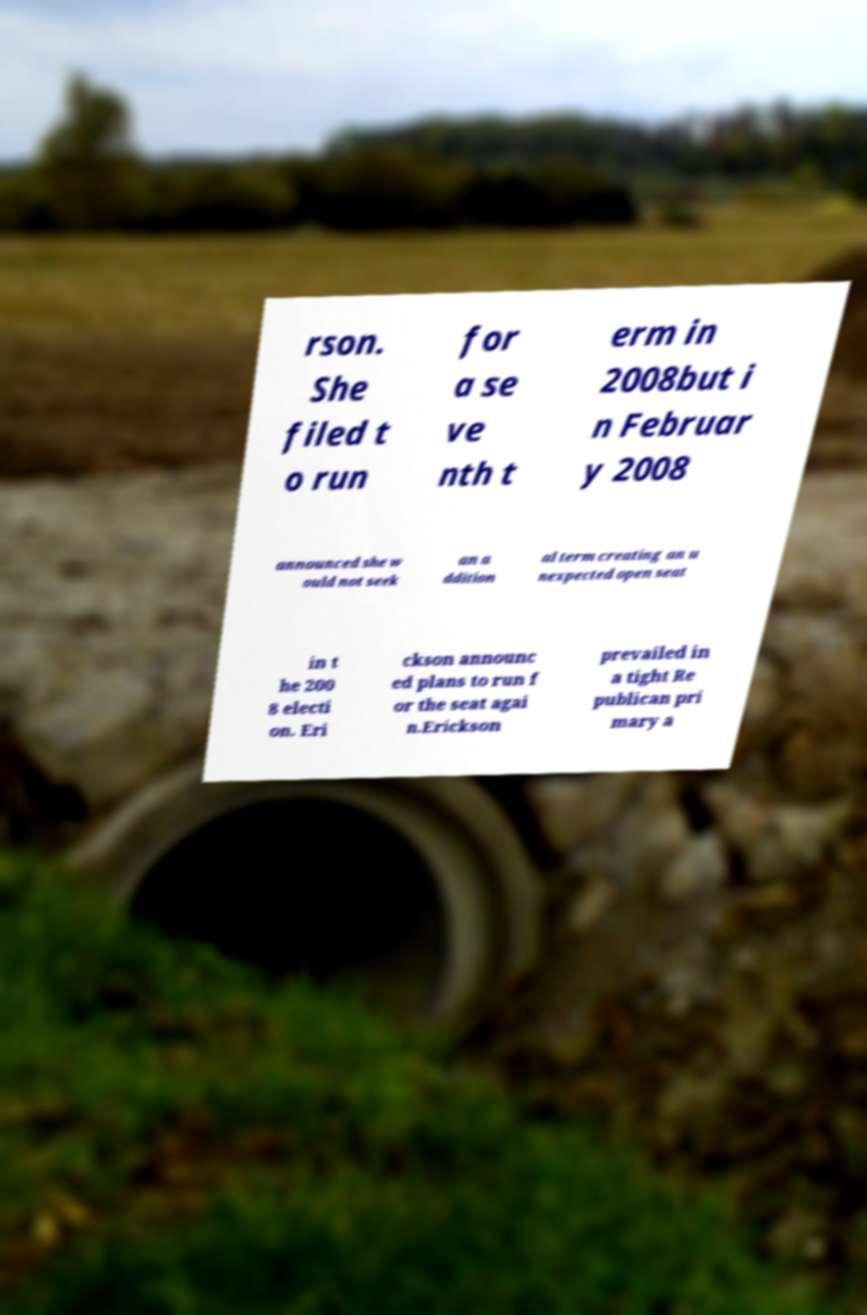There's text embedded in this image that I need extracted. Can you transcribe it verbatim? rson. She filed t o run for a se ve nth t erm in 2008but i n Februar y 2008 announced she w ould not seek an a ddition al term creating an u nexpected open seat in t he 200 8 electi on. Eri ckson announc ed plans to run f or the seat agai n.Erickson prevailed in a tight Re publican pri mary a 